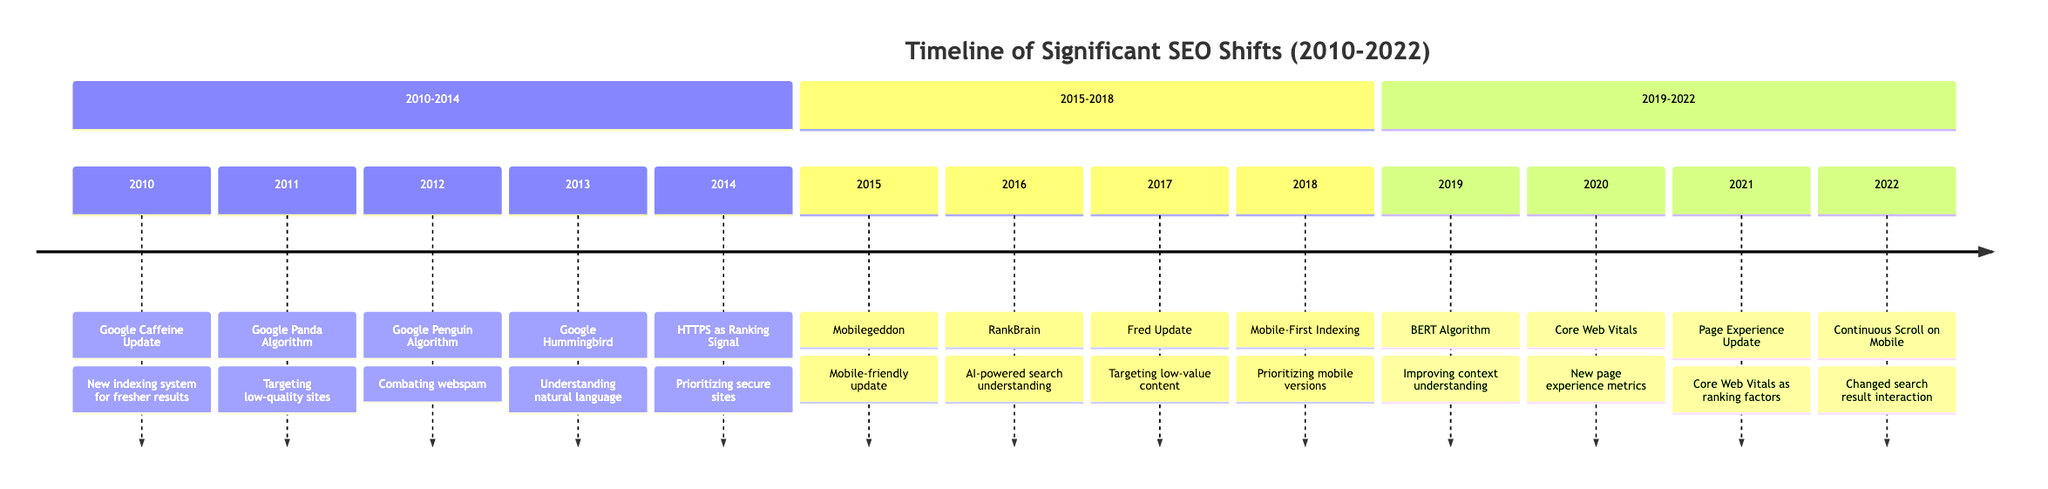What event occurred in 2011? The diagram shows that in 2011, the event was the "Google Panda Algorithm Update."
Answer: Google Panda Algorithm Update How many updates were made between 2015 and 2018? By counting the events listed in the section from 2015 to 2018, there are four updates: Mobilegeddon, RankBrain, Fred Update, and Mobile-First Indexing.
Answer: 4 Which algorithm was introduced in 2016? The timeline indicates that in 2016, "RankBrain" was introduced as a significant update.
Answer: RankBrain What is the focus of the Core Web Vitals introduced in 2020? The Core Web Vitals focus on page experience metrics related to loading speed, interactivity, and visual stability, as indicated in the timeline.
Answer: Page experience Which event relates to mobile search in 2022? According to the timeline, the event for 2022 related to mobile search is "Continuous Scroll on Mobile."
Answer: Continuous Scroll on Mobile Which update aimed at low-value content sites? The Fred Update, introduced in 2017, specifically targeted low-value content sites.
Answer: Fred Update What significant change to indexing occurred in 2018? In 2018, the event "Mobile-First Indexing" significantly changed the way websites were indexed and ranked, prioritizing mobile versions.
Answer: Mobile-First Indexing Describe the relationship between HTTPS and ranking in 2014. The diagram states that in 2014, "HTTPS as a Ranking Signal" was introduced, establishing a direct relationship where secure sites were prioritized in rankings.
Answer: HTTPS as a Ranking Signal What was the primary goal of the Google Hummingbird update in 2013? The primary goal of the Google Hummingbird update was to improve understanding of natural language queries, as indicated in the event description.
Answer: Understanding natural language 